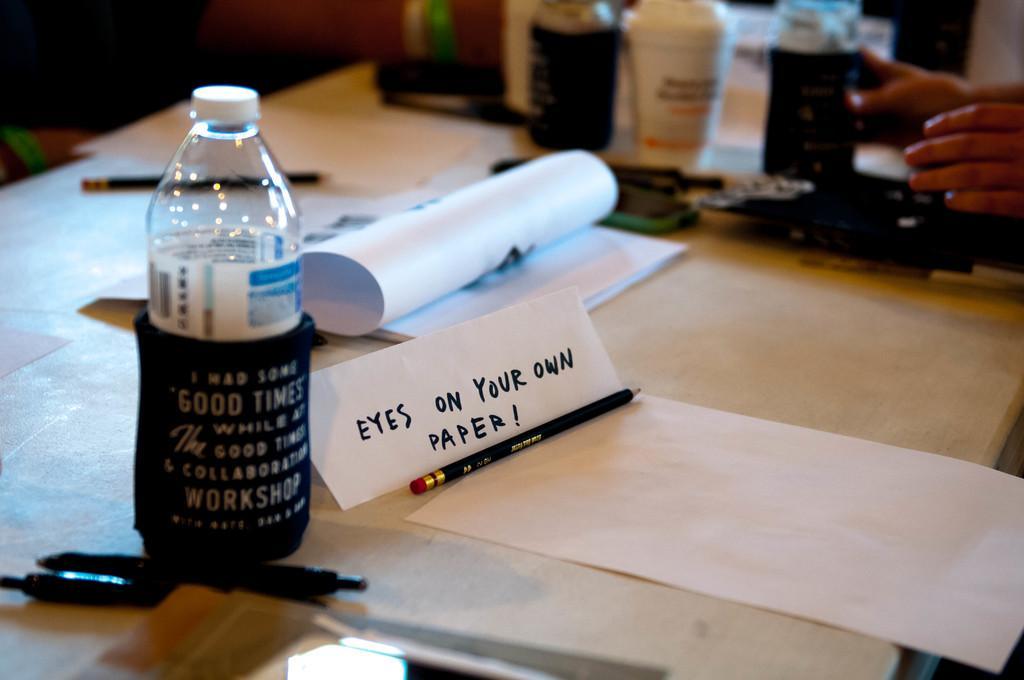Can you describe this image briefly? In this image, There is a table of white color, there is a bottle , There is a book there are some objects, There is a pen, there is a pencil on the table. 